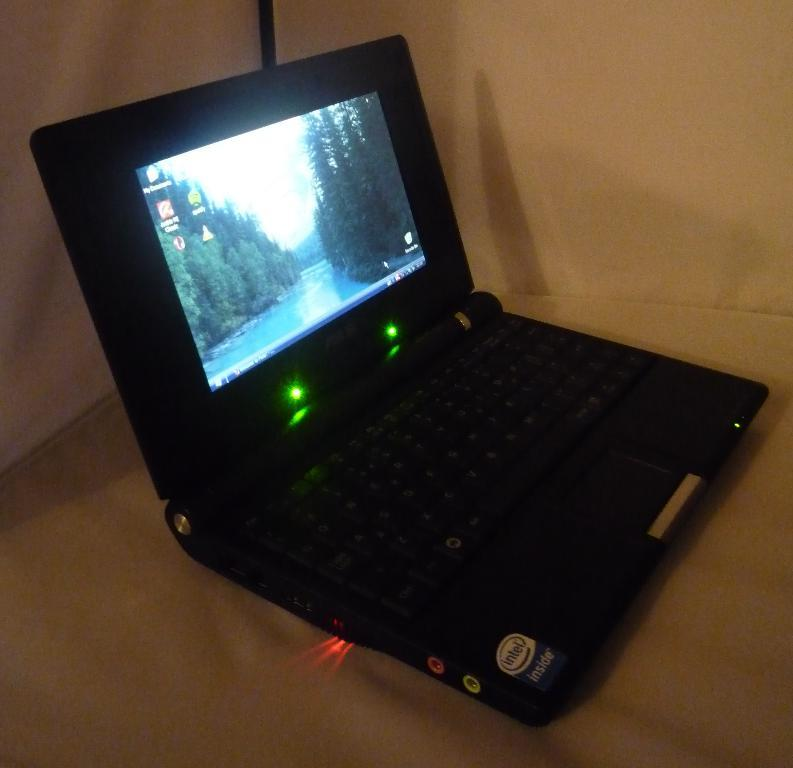What type of electronic device is visible in the image? There is a black color laptop in the image. What is the color of the background in the image? The background of the image is white. What type of seashore can be seen in the background of the image? There is no seashore present in the image; it features a black color laptop on a white background. What type of mineral is visible in the image? There is no mineral present in the image; it features a black color laptop on a white background. 